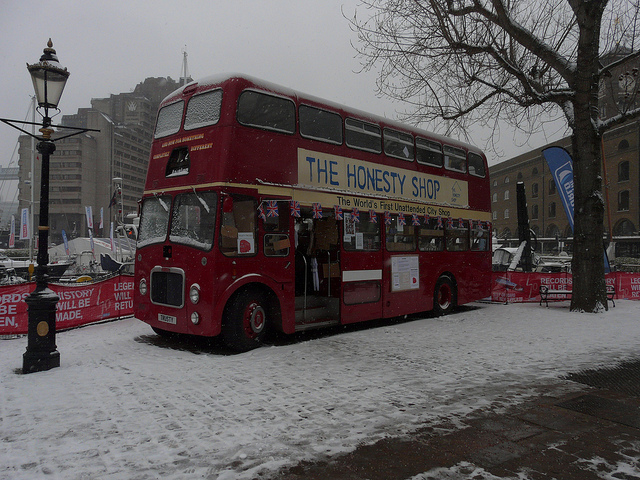<image>On what social networks can this food truck be found? I am not sure on which social networks this food truck can be found. It might be on Facebook or Twitter. On what social networks can this food truck be found? This food truck can be found on Facebook. 